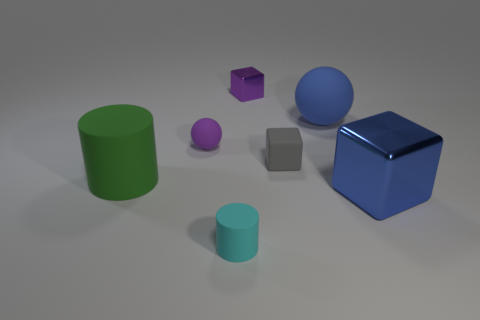There is a big object that is to the left of the metal object that is on the left side of the blue metal cube; is there a small rubber block that is in front of it?
Your response must be concise. No. There is a gray thing that is the same shape as the big blue metallic thing; what is it made of?
Your answer should be compact. Rubber. How many big blue rubber balls are in front of the purple object that is to the right of the small cylinder?
Provide a succinct answer. 1. There is a rubber sphere that is to the right of the cube behind the big blue thing that is on the left side of the blue metallic object; what is its size?
Your answer should be compact. Large. What is the color of the cylinder behind the rubber cylinder in front of the blue cube?
Your response must be concise. Green. How many other objects are the same material as the gray thing?
Give a very brief answer. 4. How many other objects are the same color as the small metallic thing?
Give a very brief answer. 1. What material is the big thing on the left side of the matte cylinder to the right of the large cylinder?
Keep it short and to the point. Rubber. Are there any purple things?
Provide a succinct answer. Yes. There is a green thing that is on the left side of the tiny cube in front of the tiny purple shiny thing; how big is it?
Your answer should be compact. Large. 